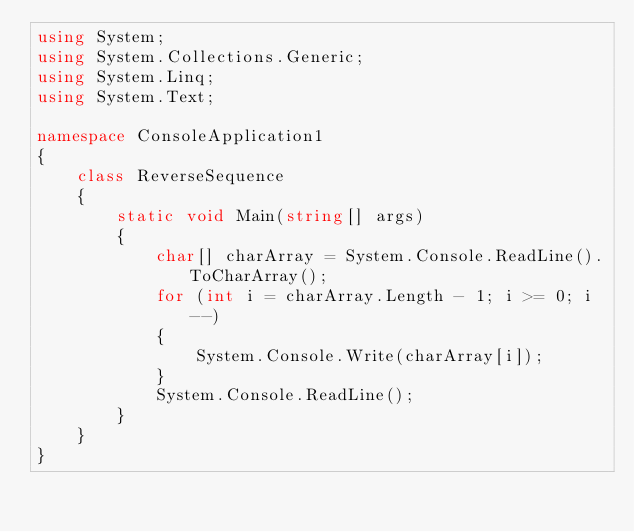Convert code to text. <code><loc_0><loc_0><loc_500><loc_500><_C#_>using System;
using System.Collections.Generic;
using System.Linq;
using System.Text;

namespace ConsoleApplication1
{
    class ReverseSequence
    {
        static void Main(string[] args)
        {
            char[] charArray = System.Console.ReadLine().ToCharArray();
            for (int i = charArray.Length - 1; i >= 0; i--)
            {
                System.Console.Write(charArray[i]);
            }
            System.Console.ReadLine();
        }
    }
}</code> 